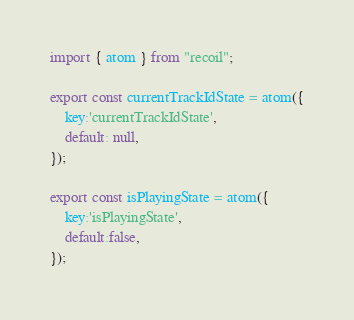Convert code to text. <code><loc_0><loc_0><loc_500><loc_500><_JavaScript_>import { atom } from "recoil";

export const currentTrackIdState = atom({
    key:'currentTrackIdState',
    default: null,
});

export const isPlayingState = atom({
    key:'isPlayingState',
    default:false,
});</code> 